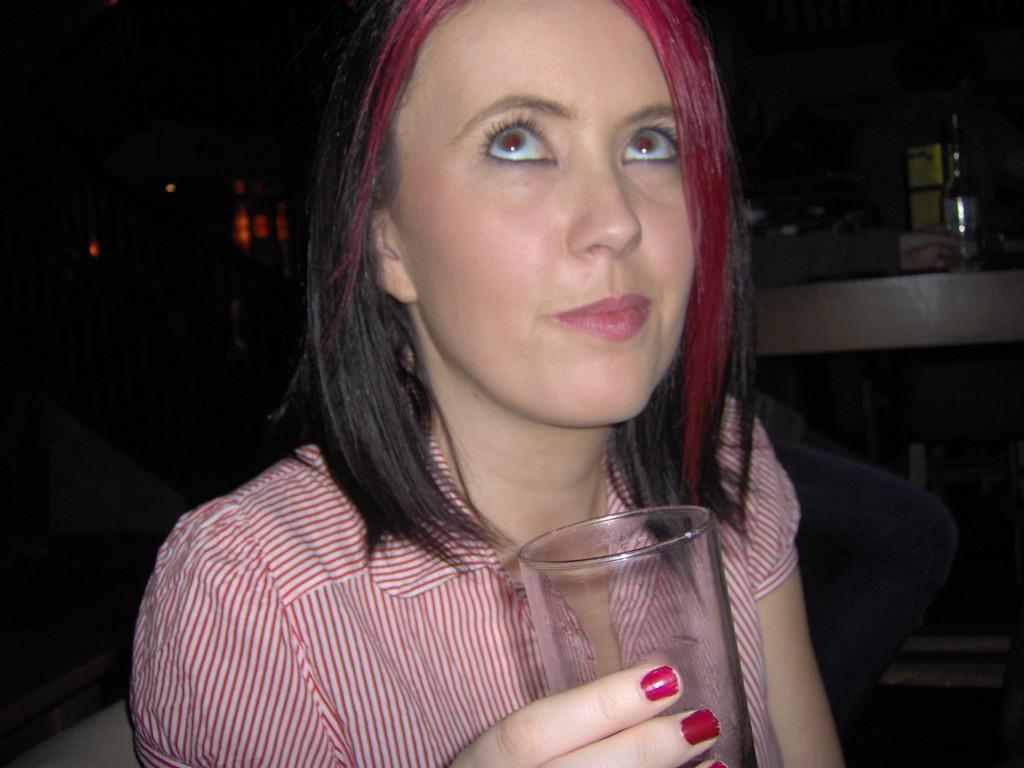Please provide a concise description of this image. In this image in the foreground there is one woman who is holding a glass and in the background there are some tables, and one person is sitting and also there is one bottle. 